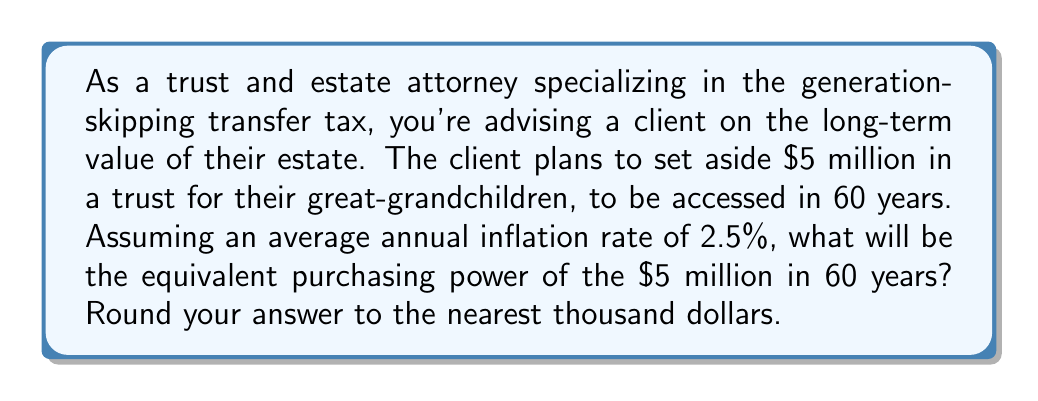Can you answer this question? To solve this problem, we need to use an exponential model that accounts for inflation over time. The formula for calculating the future value adjusted for inflation is:

$$FV = PV \times (1 + i)^n$$

Where:
$FV$ = Future Value (what we're solving for)
$PV$ = Present Value ($5 million)
$i$ = Annual inflation rate (2.5% or 0.025)
$n$ = Number of years (60)

Let's plug in the values:

$$FV = 5,000,000 \times (1 + 0.025)^{60}$$

Now, let's calculate:

1) First, calculate $(1 + 0.025)^{60}$:
   $$(1.025)^{60} \approx 4.4217$$

2) Multiply this by the present value:
   $$5,000,000 \times 4.4217 \approx 22,108,500$$

3) Round to the nearest thousand:
   $$22,109,000$$

This means that $5 million today will have the equivalent purchasing power of approximately $22,109,000 in 60 years, given an annual inflation rate of 2.5%.

In other words, to maintain the same purchasing power as $5 million today, the trust would need to grow to $22,109,000 in 60 years just to keep pace with inflation.
Answer: $22,109,000 